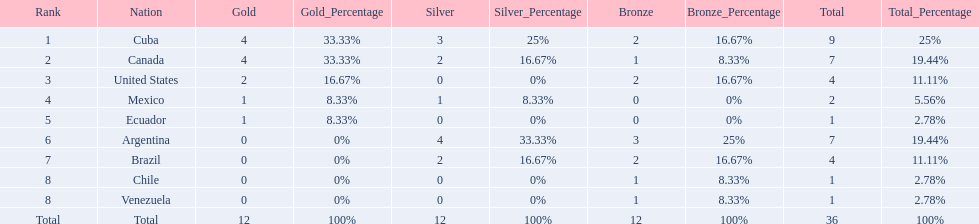Which nations won a gold medal in canoeing in the 2011 pan american games? Cuba, Canada, United States, Mexico, Ecuador. Which of these did not win any silver medals? United States. 